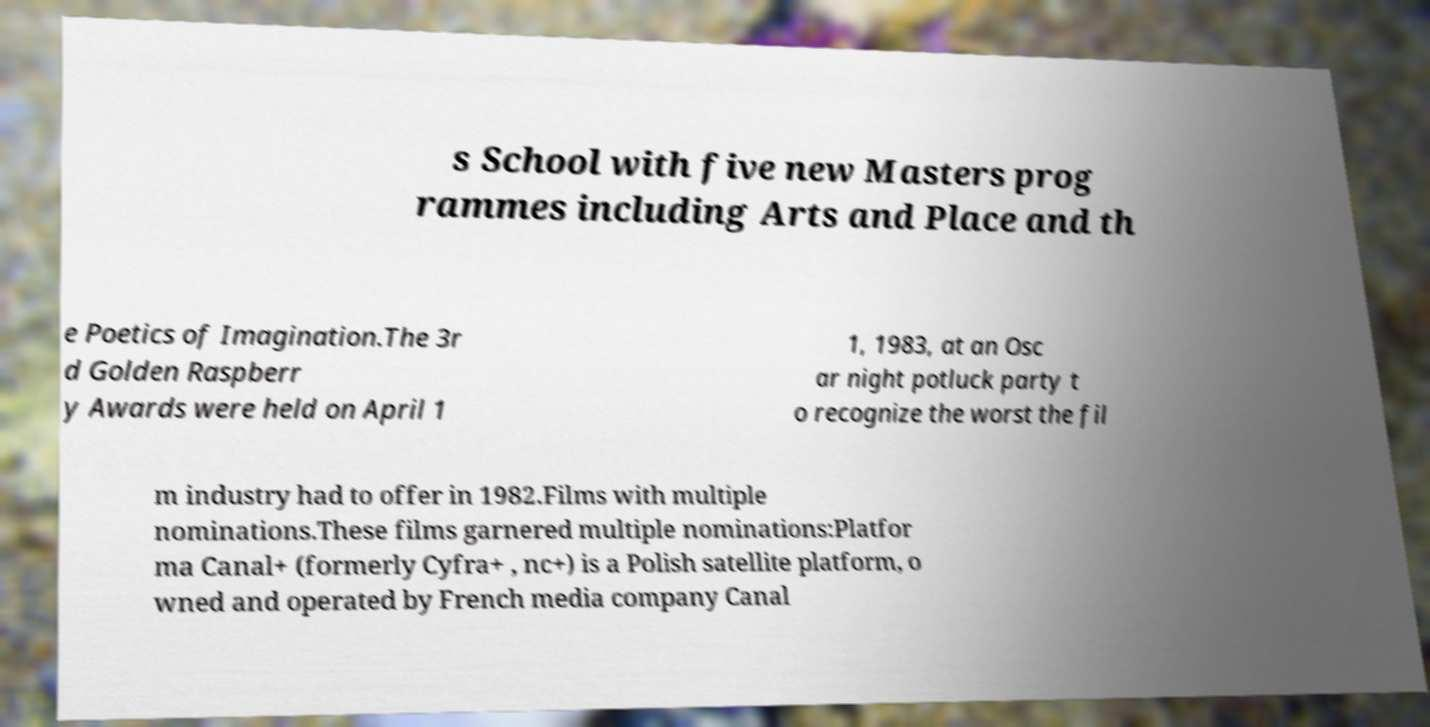What messages or text are displayed in this image? I need them in a readable, typed format. s School with five new Masters prog rammes including Arts and Place and th e Poetics of Imagination.The 3r d Golden Raspberr y Awards were held on April 1 1, 1983, at an Osc ar night potluck party t o recognize the worst the fil m industry had to offer in 1982.Films with multiple nominations.These films garnered multiple nominations:Platfor ma Canal+ (formerly Cyfra+ , nc+) is a Polish satellite platform, o wned and operated by French media company Canal 